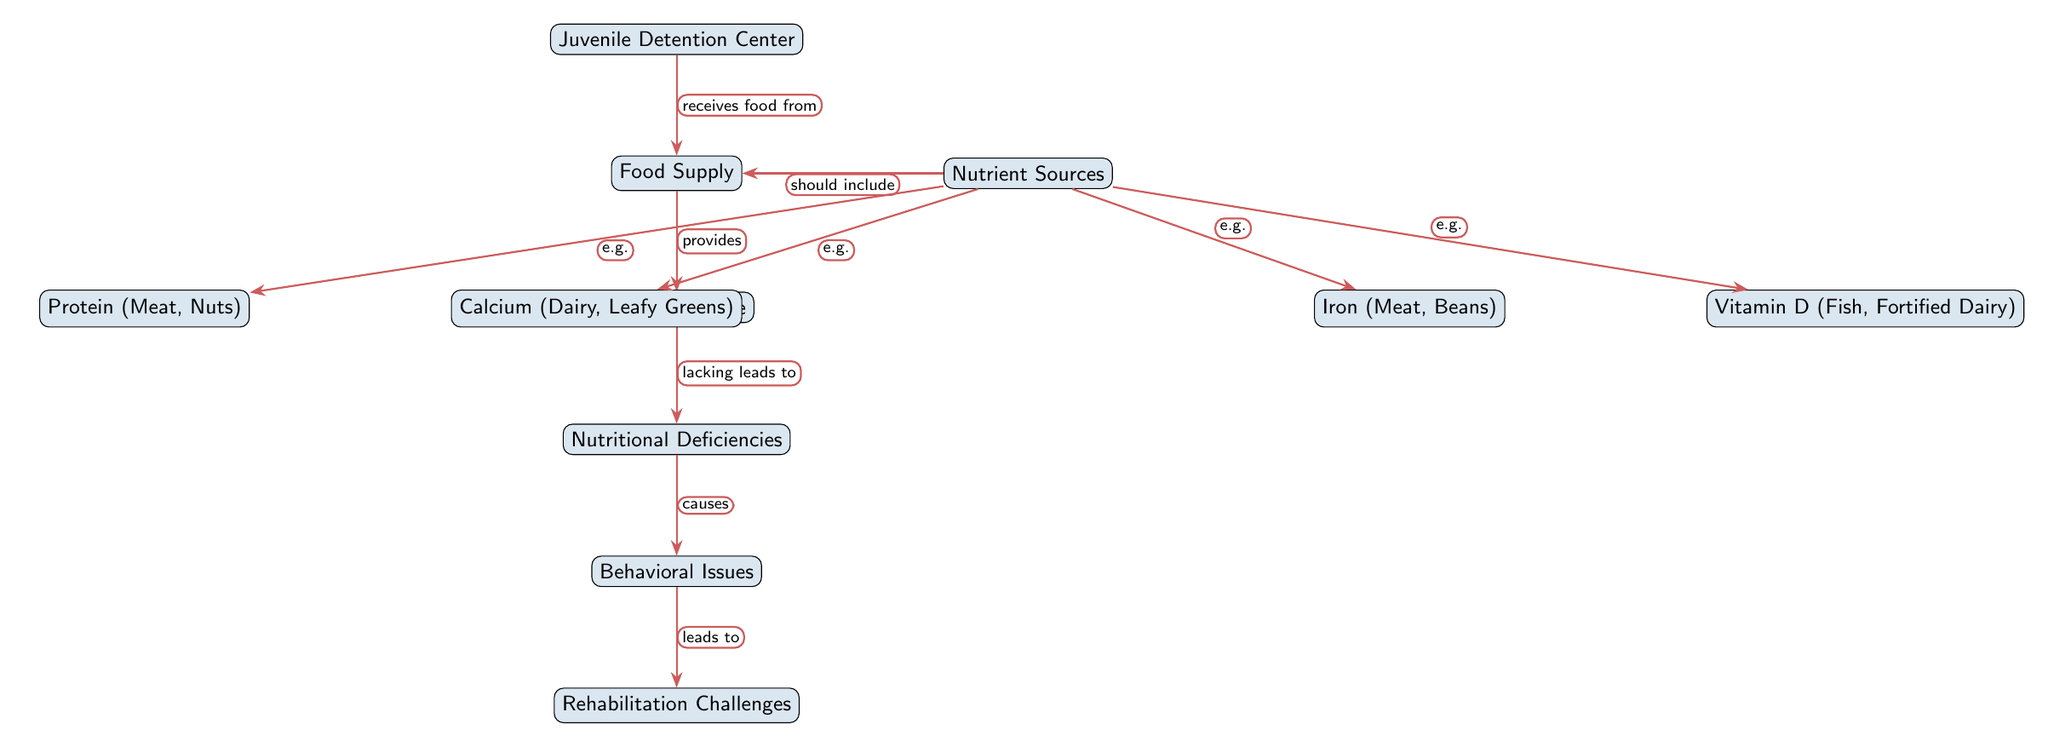What is the main entity at the top of the food chain? The top entity in the diagram is "Juvenile Detention Center," which serves as the starting point for the flow of information depicted in the food chain.
Answer: Juvenile Detention Center How many nutrient sources are listed in the diagram? There are four nutrient sources shown in the diagram: Iron, Vitamin D, Calcium, and Protein, which can be counted from the right side of the food supply node.
Answer: 4 What nutrient is associated with meat and beans? The diagram indicates that "Iron" is associated with nutrient sources like meat and beans, providing a direct link to the specific foods listed.
Answer: Iron What do nutritional deficiencies lead to in the diagram? From the flow of information in the diagram, "Nutritional Deficiencies" directly lead to "Behavioral Issues," which is indicated by the causal relationship between these two nodes.
Answer: Behavioral Issues Which nutrient source is linked to dairy? The diagram specifically lists "Calcium" as linked to dairy, which is identifiable from the nutrient sources section of the food supply node.
Answer: Calcium What is the connection between food supply and nutrient intake? The diagram shows that the "Food Supply" provides "Nutrient Intake," indicating a direct relationship where food supply leads to the intake of nutrients by the juveniles in the detention center.
Answer: provides What are the behavioral outcomes of nutritional deficiencies according to the diagram? The flow of the diagram indicates that "Nutritional Deficiencies" cause "Behavioral Issues," thus establishing a direct link in the outcomes of deficiencies on behavior.
Answer: Behavioral Issues Which nutrient source is specifically indicated for fortified dairy? The diagram explicitly states "Vitamin D" as linked to "Fortified Dairy," highlighting that this nutrient is particularly associated with dairy products that are fortified.
Answer: Vitamin D What is the last node in the food chain? The last node in the diagram is "Rehabilitation Challenges," indicating the endpoint of the flow of consequences stemming from nutritional deficiencies.
Answer: Rehabilitation Challenges 